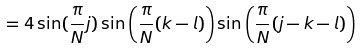Convert formula to latex. <formula><loc_0><loc_0><loc_500><loc_500>= 4 \sin ( \frac { \pi } { N } j ) \sin \left ( \frac { \pi } { N } ( k - l ) \right ) \sin \left ( \frac { \pi } { N } ( j - k - l ) \right )</formula> 